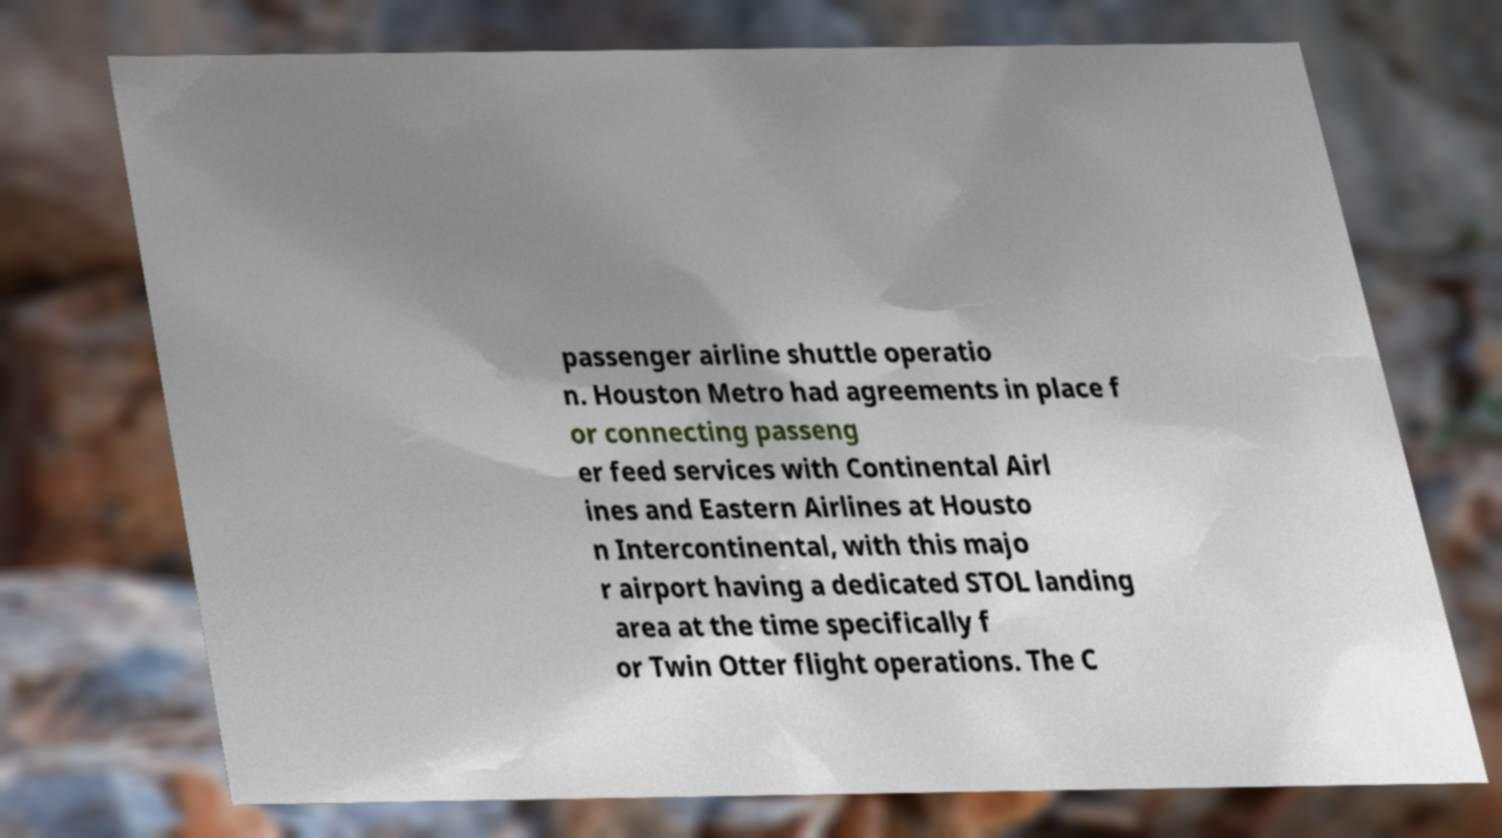There's text embedded in this image that I need extracted. Can you transcribe it verbatim? passenger airline shuttle operatio n. Houston Metro had agreements in place f or connecting passeng er feed services with Continental Airl ines and Eastern Airlines at Housto n Intercontinental, with this majo r airport having a dedicated STOL landing area at the time specifically f or Twin Otter flight operations. The C 